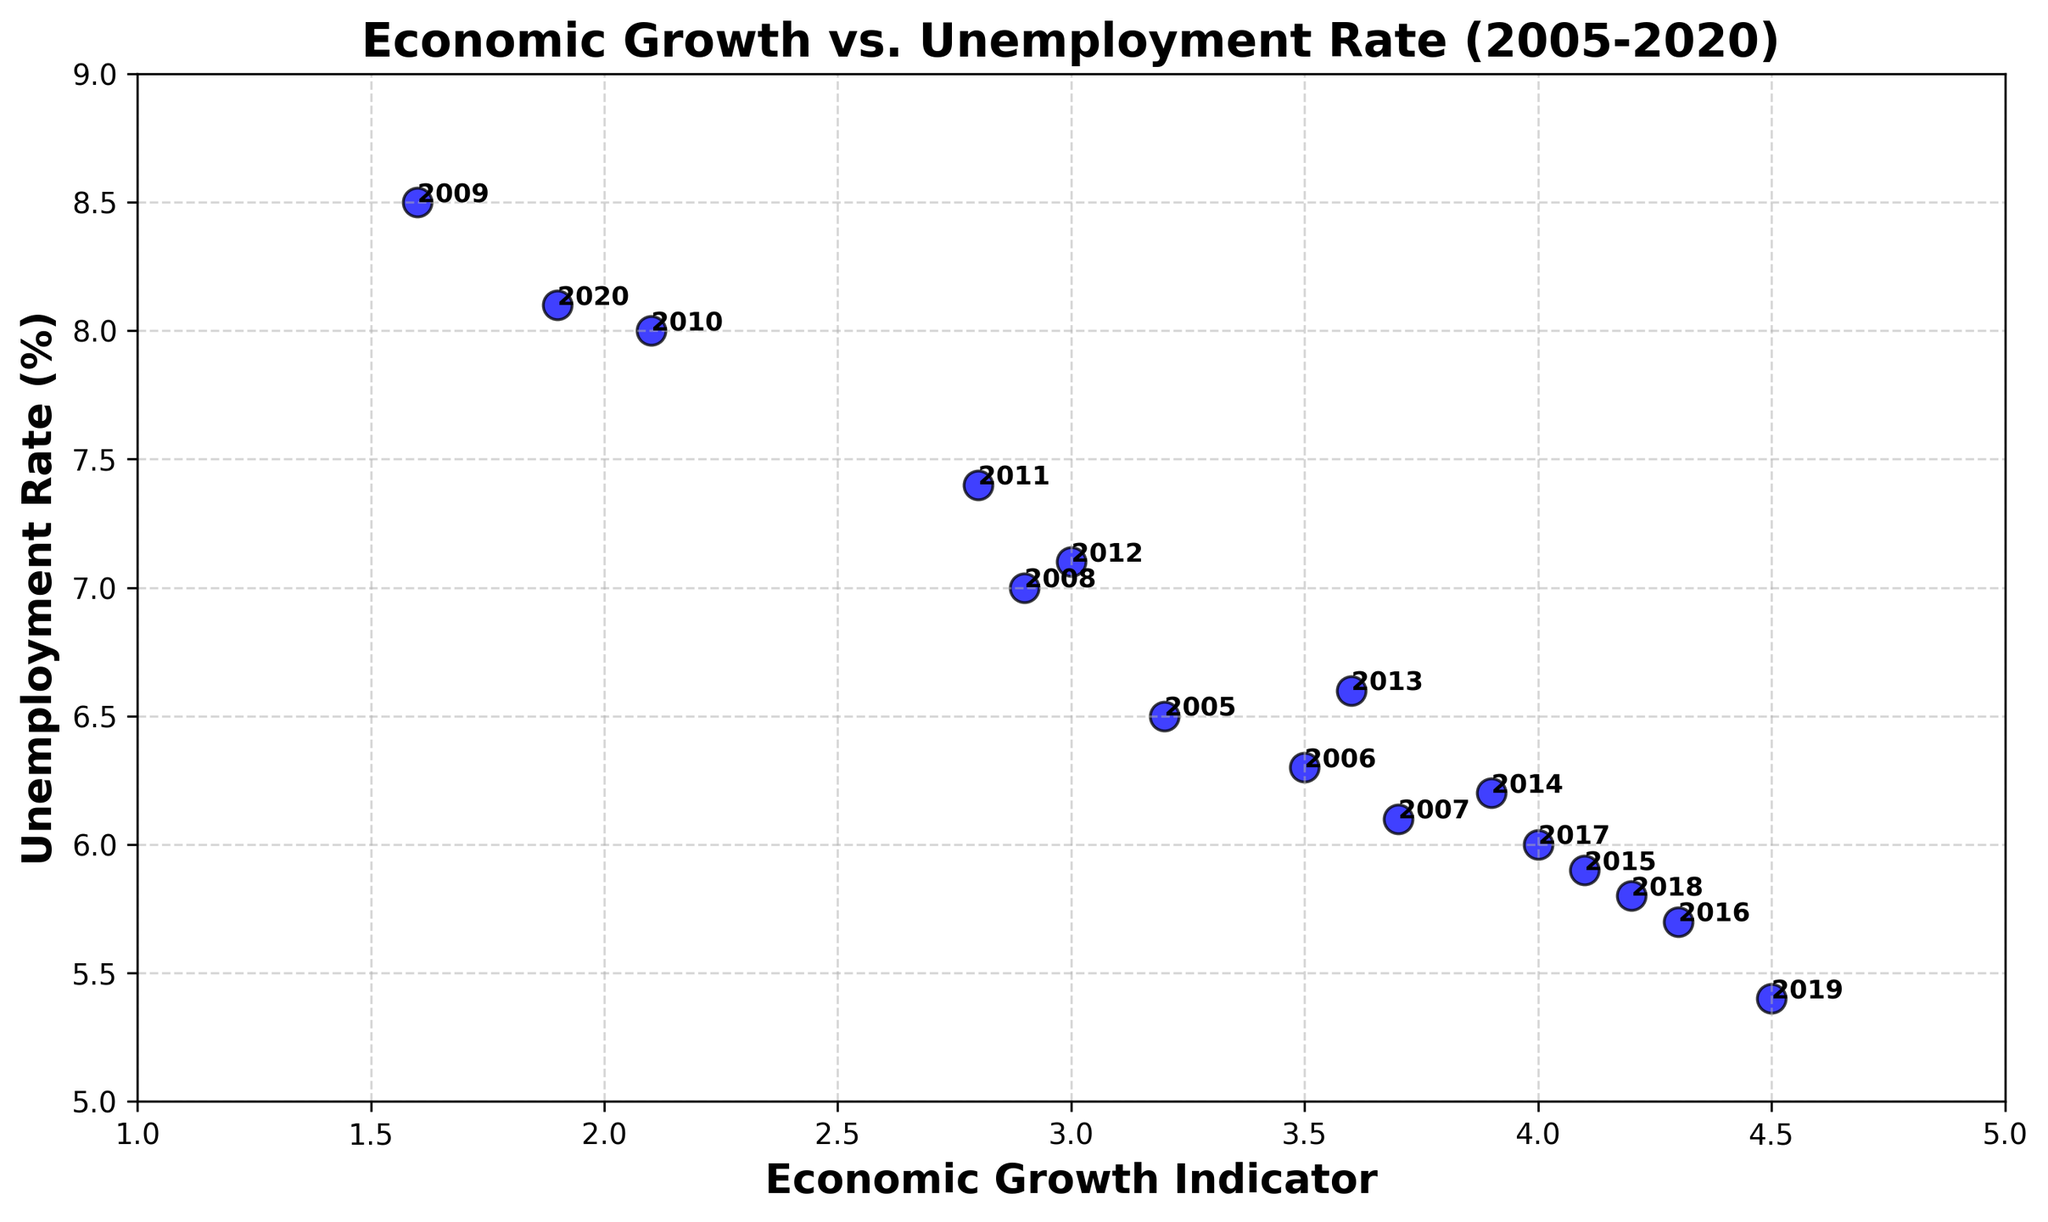What year had the lowest Economic Growth Indicator, and what was the corresponding Unemployment Rate? To find the year with the lowest Economic Growth Indicator, look for the minimum value along the Economic Growth Indicator axis and note the corresponding year and Unemployment Rate. The minimum Economic Growth Indicator is 1.6 in 2009, with an Unemployment Rate of 8.5%.
Answer: 2009, 8.5% During which year did the city experience the highest Economic Growth Indicator, and what was the Unemployment Rate during that year? Identify the year with the highest Economic Growth Indicator value on the plot. The highest Economic Growth Indicator is 4.5 in 2019, with an Unemployment Rate of 5.4%.
Answer: 2019, 5.4% Compare the Unemployment Rates between the years 2009 and 2010. Which year had a higher rate and by how much? Look at the Unemployment Rates for 2009 and 2010 on the y-axis. In 2009, the rate is 8.5%, and in 2010 it is 8.0%. 2009 had a higher rate by 0.5%.
Answer: 2009, 0.5% What is the average Economic Growth Indicator for the years 2016 to 2019 (inclusive)? Add the Economic Growth Indicator values for 2016, 2017, 2018, and 2019, then divide by the number of years: (4.3 + 4.0 + 4.2 + 4.5) / 4 = 17 / 4 = 4.25.
Answer: 4.25 Is there any year where the Unemployment Rate is higher than 8% despite the Economic Growth Indicator being above 2%? If yes, name the year. Look for data points where the Economic Growth Indicator is greater than 2% and the Unemployment Rate is higher than 8%. The year 2020 shows an Economic Growth Indicator of 1.9% and an Unemployment Rate of 8.1%, but 2010 shows an Economic Growth Indicator of 2.1% and an Unemployment Rate of 8.0%. No year meets both criteria strictly.
Answer: No What is the range of Unemployment Rates observed in the figure? The range is calculated as the difference between the maximum and minimum Unemployment Rates. The maximum Unemployment Rate is 8.5% (2009) and the minimum is 5.4% (2019). The range is 8.5% - 5.4% = 3.1%.
Answer: 3.1% During which years did the city have an Economic Growth Indicator greater than 4%, and what were the corresponding Unemployment Rates? Identify all instances where the Economic Growth Indicator exceeds 4%. The years are 2016 (5.7%), 2019 (5.4%), 2018 (5.8%), and 2015 (5.9%). List the years with their respective Unemployment Rates.
Answer: 2016 (5.7%), 2019 (5.4%), 2018 (5.8%), 2015 (5.9%) Does the data show any visual trend between Economic Growth Indicator and Unemployment Rate? Observe the overall pattern formed by the scatter plot. Typically, as the Economic Growth Indicator increases, the Unemployment Rate tends to decrease, suggesting an inverse relationship.
Answer: Inverse relationship Which year had the second-highest Economic Growth Indicator, and what was the corresponding Unemployment Rate? Identify the year with the second-highest Economic Growth Indicator value. The highest is 4.5 in 2019, and the second-highest is 4.3 in 2016, with an Unemployment Rate of 5.7%.
Answer: 2016, 5.7% In which year did the Unemployment Rate decrease the most from the previous year, and by how much? Compare the year-over-year differences in Unemployment Rate and identify the largest decrease. The largest decrease is from 2010 to 2011, 8.0% - 7.4% = 0.6%.
Answer: 2011, 0.6% 